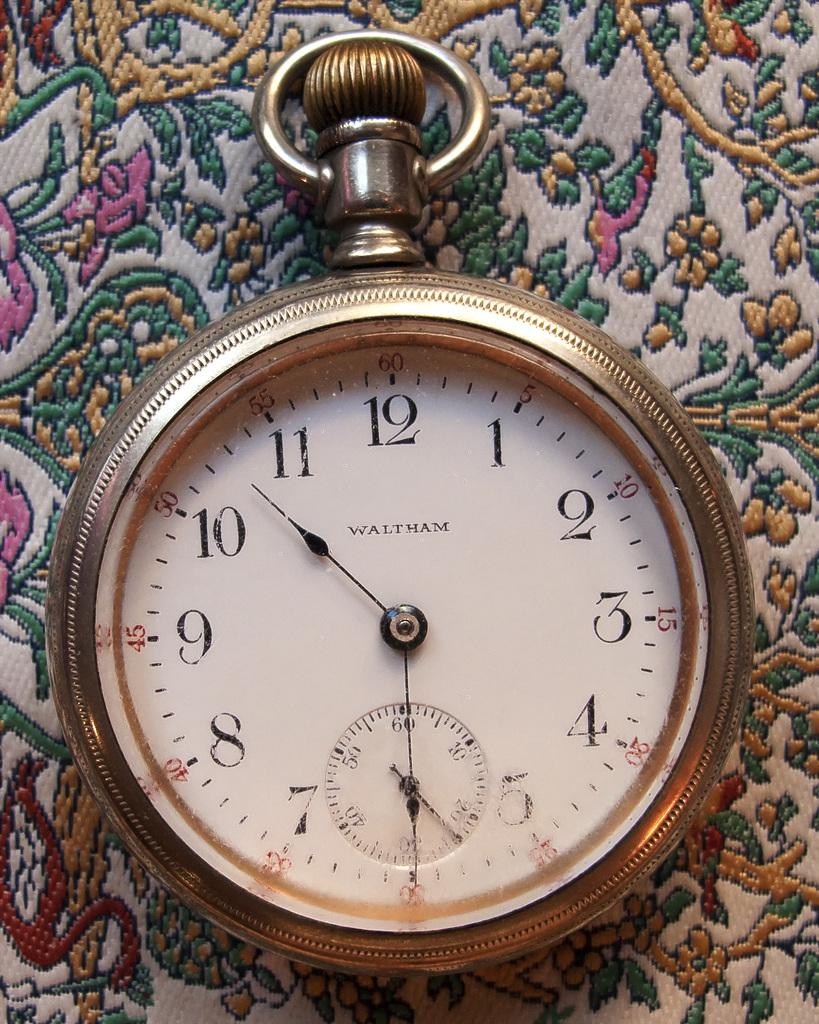<image>
Describe the image concisely. A watch created by WALTHAM displaying the time 6:53. 